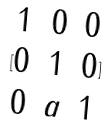Convert formula to latex. <formula><loc_0><loc_0><loc_500><loc_500>[ \begin{matrix} 1 & 0 & 0 \\ 0 & 1 & 0 \\ 0 & a & 1 \end{matrix} ]</formula> 